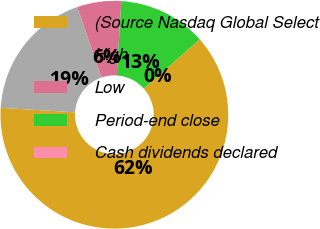<chart> <loc_0><loc_0><loc_500><loc_500><pie_chart><fcel>(Source Nasdaq Global Select<fcel>High<fcel>Low<fcel>Period-end close<fcel>Cash dividends declared<nl><fcel>62.47%<fcel>18.75%<fcel>6.26%<fcel>12.5%<fcel>0.01%<nl></chart> 